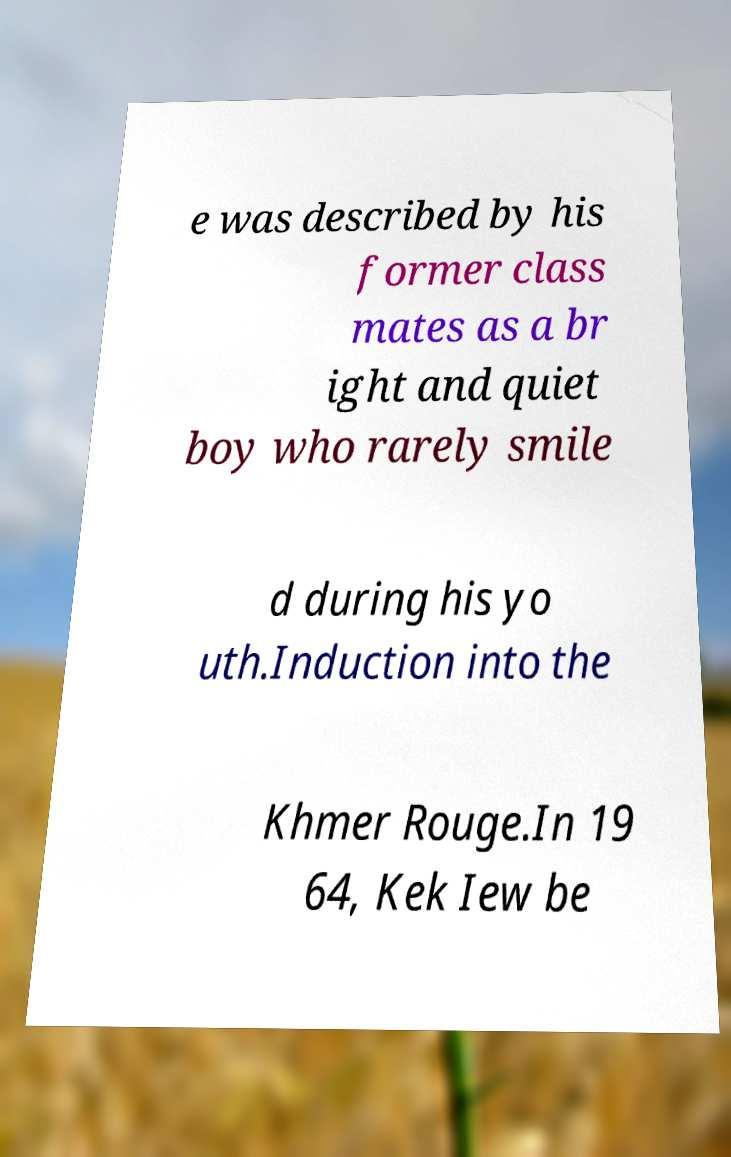Please read and relay the text visible in this image. What does it say? e was described by his former class mates as a br ight and quiet boy who rarely smile d during his yo uth.Induction into the Khmer Rouge.In 19 64, Kek Iew be 